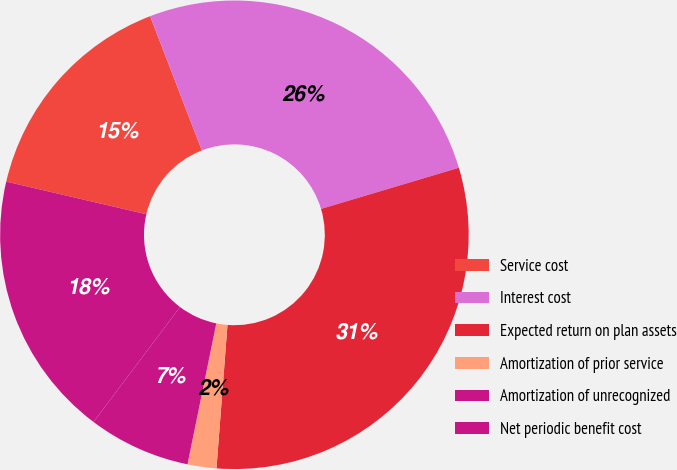<chart> <loc_0><loc_0><loc_500><loc_500><pie_chart><fcel>Service cost<fcel>Interest cost<fcel>Expected return on plan assets<fcel>Amortization of prior service<fcel>Amortization of unrecognized<fcel>Net periodic benefit cost<nl><fcel>15.5%<fcel>26.24%<fcel>30.84%<fcel>1.99%<fcel>7.06%<fcel>18.38%<nl></chart> 